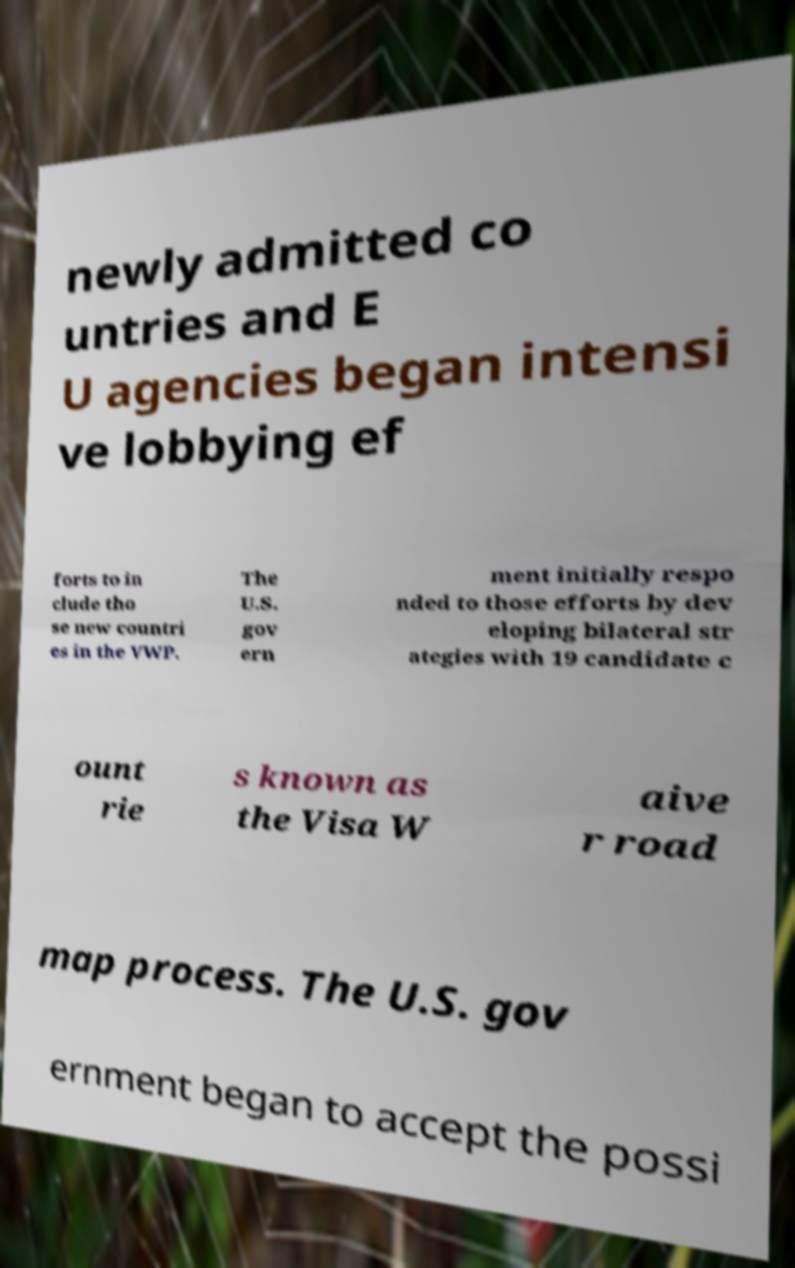Please read and relay the text visible in this image. What does it say? newly admitted co untries and E U agencies began intensi ve lobbying ef forts to in clude tho se new countri es in the VWP. The U.S. gov ern ment initially respo nded to those efforts by dev eloping bilateral str ategies with 19 candidate c ount rie s known as the Visa W aive r road map process. The U.S. gov ernment began to accept the possi 